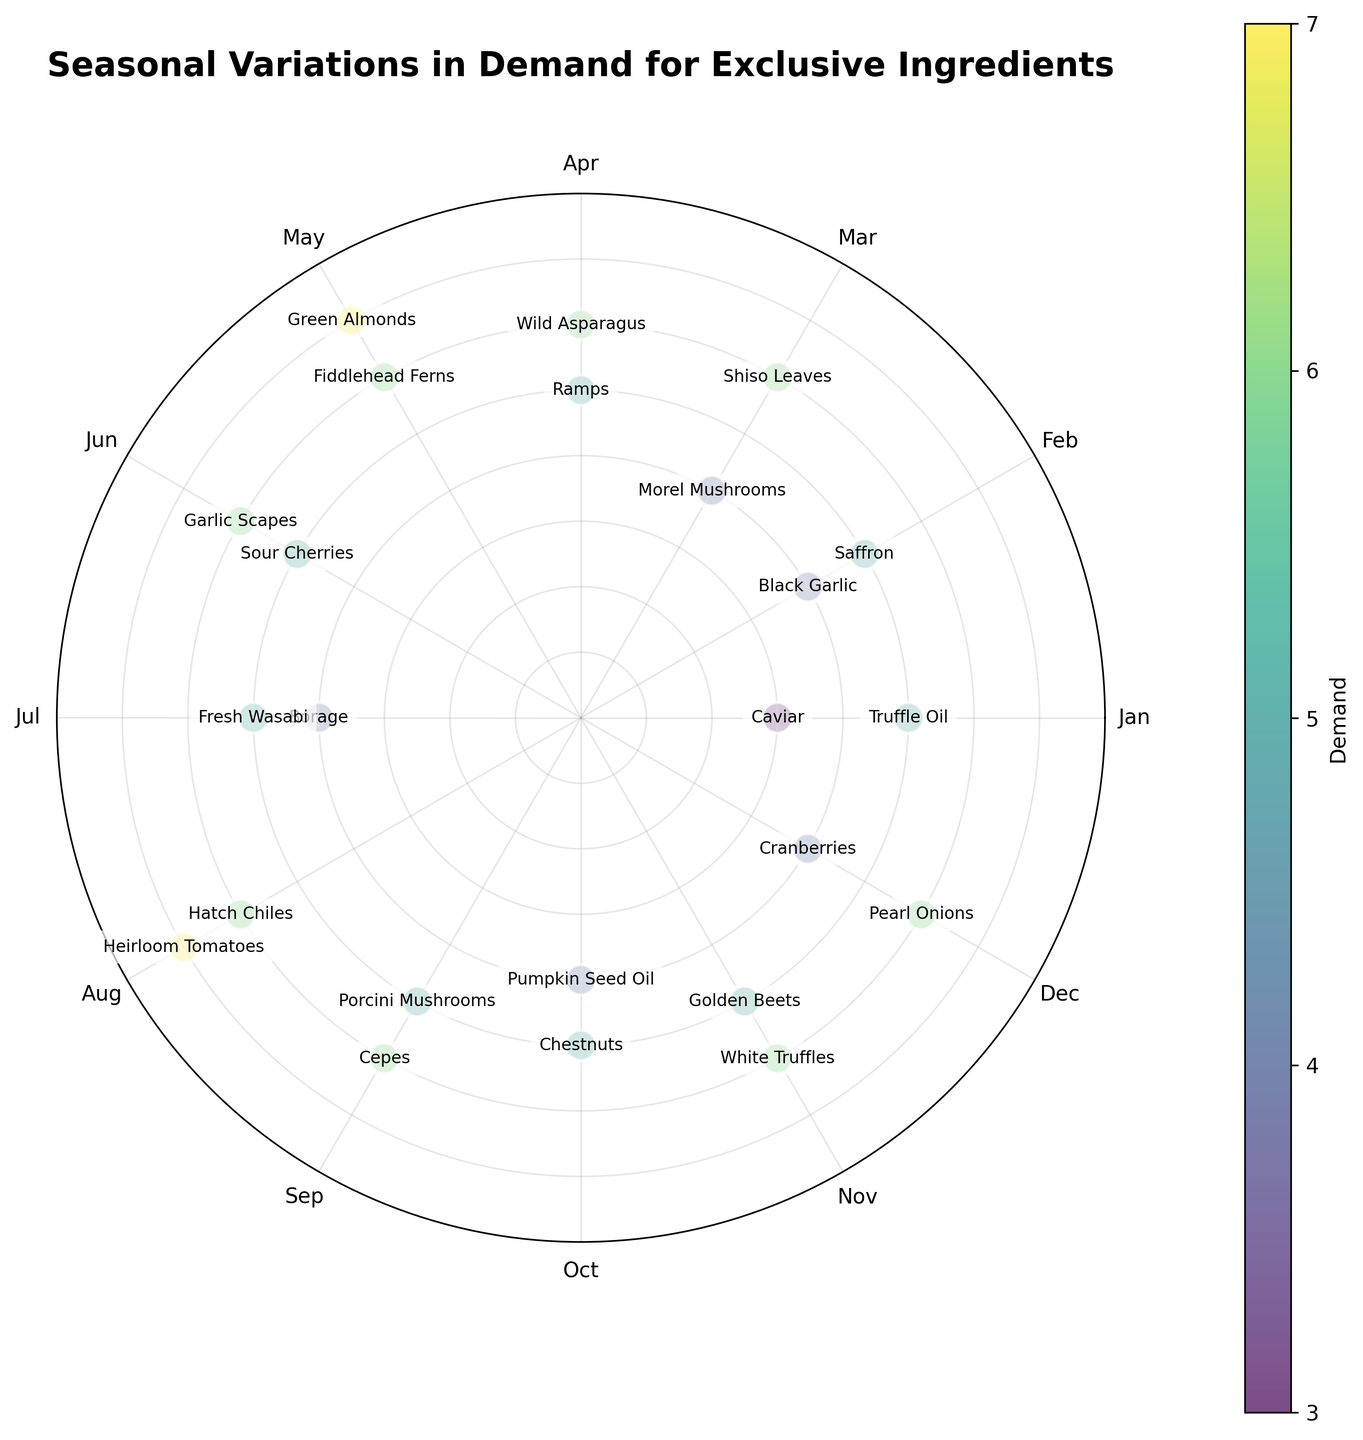Which month has the highest demand for exclusive ingredients? To find the month with the highest demand, refer to the radial positions and the demand values. The highest demand plotted on the outermost circle is 7, visible in May and August.
Answer: May and August What is the average demand for ingredients in January? January has two data points: Truffle Oil with a demand of 5 and Caviar with a demand of 3. The average demand is (5+3)/2 = 4.
Answer: 4 Which ingredient has the highest demand, and in what month is it? Identify the ingredient positioned furthest from the center of the chart. The furthest data points are Green Almonds and Heirloom Tomatoes, both with a demand of 7, in May and August respectively.
Answer: Green Almonds (May) and Heirloom Tomatoes (August) What's the difference in demand between Fiddlehead Ferns and Morel Mushrooms? Fiddlehead Ferns have a demand of 6 in May and Morel Mushrooms have a demand of 4 in March. The difference is 6 - 4 = 2.
Answer: 2 Which months have more than one ingredient with the same demand level? Look for months with multiple data points at the same radial distance. February shows two ingredients, Black Garlic and Saffron, both with a demand of 4, and December shows Pearl Onions and Cranberries both with a demand of 6.
Answer: February and December What is the median demand across all ingredients? List all demand values: 3, 4, 4, 4, 5, 5, 5, 5, 5, 5, 5, 6, 6, 6, 6, 6, 6, 7, 7. There are 19 data points, thus the median is the 10th value in the sorted list, which is 5.
Answer: 5 How does the demand for Chestnuts in October compare to the average demand for all ingredients? Chestnuts in October have a demand of 5. The average demand across all ingredients is (sum of all demands 98 / number of data points 19) = 5.16. Chestnuts' demand is slightly below the average.
Answer: Slightly below What ingredient has the lowest demand and in what month does this occur? Identify the inner data point closest to the center. Caviar in January has the lowest demand of 3.
Answer: Caviar (January) How many ingredients have a demand level of 6? Count all data points at the radial distance corresponding to a demand of 6. They are: Shiso Leaves, Wild Asparagus, Fiddlehead Ferns, Garlic Scapes, Hatch Chiles, Cepes, White Truffles, and Pearl Onions.
Answer: 8 Is there a season where the demand for exclusive ingredients appears to peak? Observe the distribution across the months. A peak can be seen in late spring to early summer (April to August) as several high demand values (6 and 7) are noted.
Answer: Late spring to early summer (April to August) 